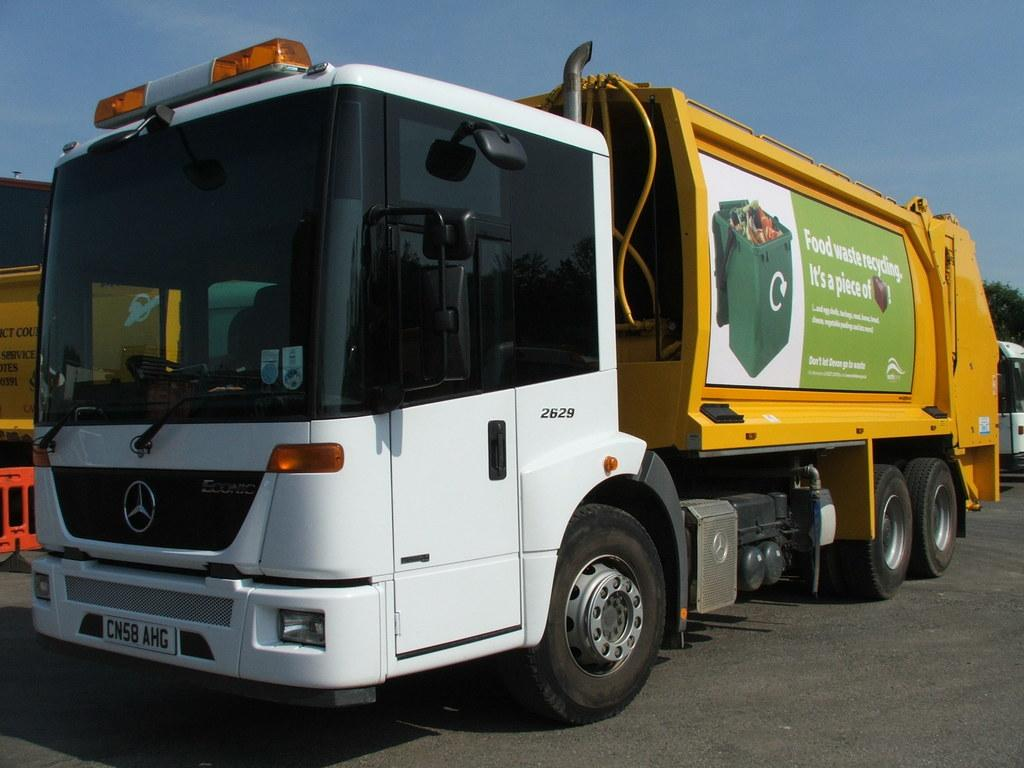Provide a one-sentence caption for the provided image. A garbage truck advertisement encourages attention to the issue of food waste recycling. 